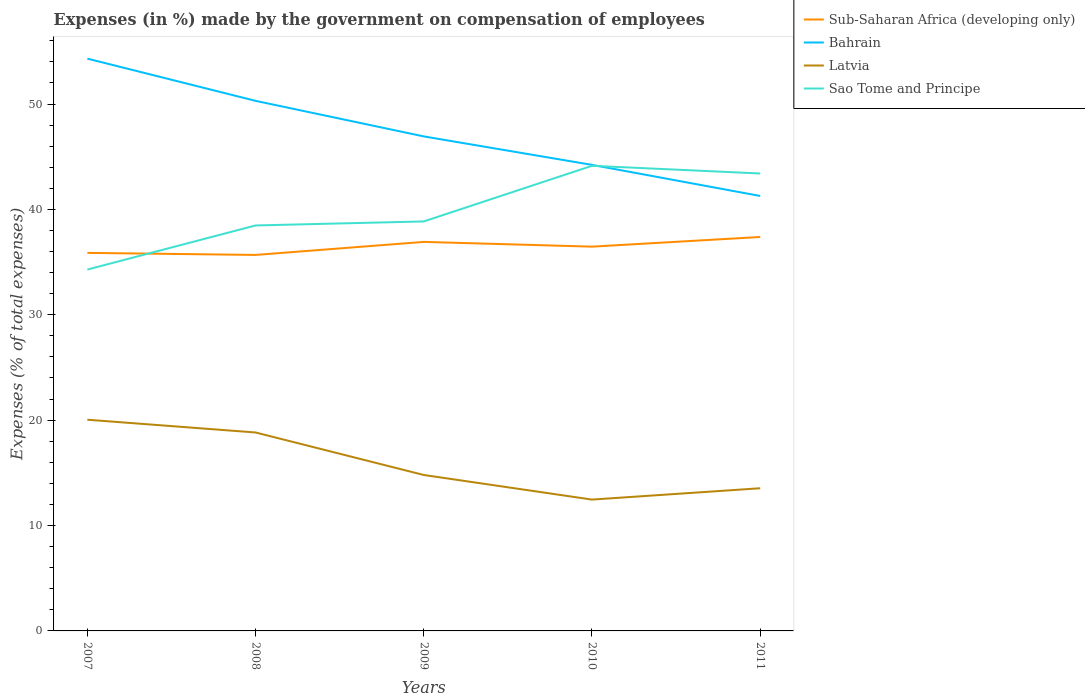How many different coloured lines are there?
Your answer should be very brief. 4. Does the line corresponding to Sub-Saharan Africa (developing only) intersect with the line corresponding to Latvia?
Make the answer very short. No. Across all years, what is the maximum percentage of expenses made by the government on compensation of employees in Sao Tome and Principe?
Your answer should be compact. 34.29. What is the total percentage of expenses made by the government on compensation of employees in Latvia in the graph?
Your answer should be compact. 2.33. What is the difference between the highest and the second highest percentage of expenses made by the government on compensation of employees in Sub-Saharan Africa (developing only)?
Your answer should be compact. 1.7. Is the percentage of expenses made by the government on compensation of employees in Sao Tome and Principe strictly greater than the percentage of expenses made by the government on compensation of employees in Latvia over the years?
Provide a succinct answer. No. Where does the legend appear in the graph?
Give a very brief answer. Top right. How many legend labels are there?
Your answer should be very brief. 4. How are the legend labels stacked?
Provide a short and direct response. Vertical. What is the title of the graph?
Your answer should be very brief. Expenses (in %) made by the government on compensation of employees. What is the label or title of the X-axis?
Provide a succinct answer. Years. What is the label or title of the Y-axis?
Make the answer very short. Expenses (% of total expenses). What is the Expenses (% of total expenses) in Sub-Saharan Africa (developing only) in 2007?
Provide a short and direct response. 35.87. What is the Expenses (% of total expenses) in Bahrain in 2007?
Give a very brief answer. 54.31. What is the Expenses (% of total expenses) in Latvia in 2007?
Offer a terse response. 20.04. What is the Expenses (% of total expenses) in Sao Tome and Principe in 2007?
Your answer should be very brief. 34.29. What is the Expenses (% of total expenses) of Sub-Saharan Africa (developing only) in 2008?
Offer a very short reply. 35.68. What is the Expenses (% of total expenses) in Bahrain in 2008?
Ensure brevity in your answer.  50.3. What is the Expenses (% of total expenses) of Latvia in 2008?
Keep it short and to the point. 18.83. What is the Expenses (% of total expenses) of Sao Tome and Principe in 2008?
Your answer should be compact. 38.48. What is the Expenses (% of total expenses) of Sub-Saharan Africa (developing only) in 2009?
Offer a very short reply. 36.91. What is the Expenses (% of total expenses) of Bahrain in 2009?
Offer a very short reply. 46.93. What is the Expenses (% of total expenses) of Latvia in 2009?
Provide a short and direct response. 14.8. What is the Expenses (% of total expenses) of Sao Tome and Principe in 2009?
Ensure brevity in your answer.  38.86. What is the Expenses (% of total expenses) of Sub-Saharan Africa (developing only) in 2010?
Provide a short and direct response. 36.46. What is the Expenses (% of total expenses) of Bahrain in 2010?
Keep it short and to the point. 44.22. What is the Expenses (% of total expenses) of Latvia in 2010?
Your answer should be very brief. 12.46. What is the Expenses (% of total expenses) of Sao Tome and Principe in 2010?
Your answer should be compact. 44.14. What is the Expenses (% of total expenses) in Sub-Saharan Africa (developing only) in 2011?
Keep it short and to the point. 37.38. What is the Expenses (% of total expenses) of Bahrain in 2011?
Your response must be concise. 41.27. What is the Expenses (% of total expenses) in Latvia in 2011?
Keep it short and to the point. 13.54. What is the Expenses (% of total expenses) in Sao Tome and Principe in 2011?
Offer a very short reply. 43.41. Across all years, what is the maximum Expenses (% of total expenses) of Sub-Saharan Africa (developing only)?
Offer a very short reply. 37.38. Across all years, what is the maximum Expenses (% of total expenses) of Bahrain?
Ensure brevity in your answer.  54.31. Across all years, what is the maximum Expenses (% of total expenses) of Latvia?
Offer a very short reply. 20.04. Across all years, what is the maximum Expenses (% of total expenses) in Sao Tome and Principe?
Your response must be concise. 44.14. Across all years, what is the minimum Expenses (% of total expenses) in Sub-Saharan Africa (developing only)?
Provide a short and direct response. 35.68. Across all years, what is the minimum Expenses (% of total expenses) in Bahrain?
Make the answer very short. 41.27. Across all years, what is the minimum Expenses (% of total expenses) of Latvia?
Provide a short and direct response. 12.46. Across all years, what is the minimum Expenses (% of total expenses) of Sao Tome and Principe?
Keep it short and to the point. 34.29. What is the total Expenses (% of total expenses) in Sub-Saharan Africa (developing only) in the graph?
Your answer should be compact. 182.31. What is the total Expenses (% of total expenses) of Bahrain in the graph?
Make the answer very short. 237.03. What is the total Expenses (% of total expenses) of Latvia in the graph?
Provide a short and direct response. 79.67. What is the total Expenses (% of total expenses) in Sao Tome and Principe in the graph?
Offer a very short reply. 199.16. What is the difference between the Expenses (% of total expenses) in Sub-Saharan Africa (developing only) in 2007 and that in 2008?
Provide a short and direct response. 0.2. What is the difference between the Expenses (% of total expenses) of Bahrain in 2007 and that in 2008?
Provide a succinct answer. 4.01. What is the difference between the Expenses (% of total expenses) in Latvia in 2007 and that in 2008?
Ensure brevity in your answer.  1.21. What is the difference between the Expenses (% of total expenses) of Sao Tome and Principe in 2007 and that in 2008?
Your answer should be compact. -4.19. What is the difference between the Expenses (% of total expenses) of Sub-Saharan Africa (developing only) in 2007 and that in 2009?
Your answer should be compact. -1.04. What is the difference between the Expenses (% of total expenses) of Bahrain in 2007 and that in 2009?
Your answer should be compact. 7.38. What is the difference between the Expenses (% of total expenses) in Latvia in 2007 and that in 2009?
Keep it short and to the point. 5.24. What is the difference between the Expenses (% of total expenses) of Sao Tome and Principe in 2007 and that in 2009?
Ensure brevity in your answer.  -4.57. What is the difference between the Expenses (% of total expenses) in Sub-Saharan Africa (developing only) in 2007 and that in 2010?
Offer a very short reply. -0.59. What is the difference between the Expenses (% of total expenses) in Bahrain in 2007 and that in 2010?
Make the answer very short. 10.08. What is the difference between the Expenses (% of total expenses) of Latvia in 2007 and that in 2010?
Give a very brief answer. 7.58. What is the difference between the Expenses (% of total expenses) in Sao Tome and Principe in 2007 and that in 2010?
Make the answer very short. -9.85. What is the difference between the Expenses (% of total expenses) of Sub-Saharan Africa (developing only) in 2007 and that in 2011?
Provide a succinct answer. -1.51. What is the difference between the Expenses (% of total expenses) of Bahrain in 2007 and that in 2011?
Provide a succinct answer. 13.03. What is the difference between the Expenses (% of total expenses) in Latvia in 2007 and that in 2011?
Offer a very short reply. 6.5. What is the difference between the Expenses (% of total expenses) in Sao Tome and Principe in 2007 and that in 2011?
Make the answer very short. -9.12. What is the difference between the Expenses (% of total expenses) in Sub-Saharan Africa (developing only) in 2008 and that in 2009?
Keep it short and to the point. -1.24. What is the difference between the Expenses (% of total expenses) in Bahrain in 2008 and that in 2009?
Give a very brief answer. 3.37. What is the difference between the Expenses (% of total expenses) of Latvia in 2008 and that in 2009?
Your response must be concise. 4.03. What is the difference between the Expenses (% of total expenses) in Sao Tome and Principe in 2008 and that in 2009?
Ensure brevity in your answer.  -0.38. What is the difference between the Expenses (% of total expenses) of Sub-Saharan Africa (developing only) in 2008 and that in 2010?
Your answer should be compact. -0.79. What is the difference between the Expenses (% of total expenses) of Bahrain in 2008 and that in 2010?
Your response must be concise. 6.08. What is the difference between the Expenses (% of total expenses) of Latvia in 2008 and that in 2010?
Provide a succinct answer. 6.37. What is the difference between the Expenses (% of total expenses) in Sao Tome and Principe in 2008 and that in 2010?
Your response must be concise. -5.66. What is the difference between the Expenses (% of total expenses) of Sub-Saharan Africa (developing only) in 2008 and that in 2011?
Make the answer very short. -1.7. What is the difference between the Expenses (% of total expenses) of Bahrain in 2008 and that in 2011?
Ensure brevity in your answer.  9.03. What is the difference between the Expenses (% of total expenses) of Latvia in 2008 and that in 2011?
Keep it short and to the point. 5.29. What is the difference between the Expenses (% of total expenses) in Sao Tome and Principe in 2008 and that in 2011?
Ensure brevity in your answer.  -4.93. What is the difference between the Expenses (% of total expenses) of Sub-Saharan Africa (developing only) in 2009 and that in 2010?
Your answer should be compact. 0.45. What is the difference between the Expenses (% of total expenses) of Bahrain in 2009 and that in 2010?
Your answer should be compact. 2.7. What is the difference between the Expenses (% of total expenses) of Latvia in 2009 and that in 2010?
Keep it short and to the point. 2.33. What is the difference between the Expenses (% of total expenses) of Sao Tome and Principe in 2009 and that in 2010?
Your answer should be compact. -5.28. What is the difference between the Expenses (% of total expenses) in Sub-Saharan Africa (developing only) in 2009 and that in 2011?
Keep it short and to the point. -0.47. What is the difference between the Expenses (% of total expenses) in Bahrain in 2009 and that in 2011?
Your answer should be compact. 5.65. What is the difference between the Expenses (% of total expenses) in Latvia in 2009 and that in 2011?
Give a very brief answer. 1.26. What is the difference between the Expenses (% of total expenses) in Sao Tome and Principe in 2009 and that in 2011?
Keep it short and to the point. -4.55. What is the difference between the Expenses (% of total expenses) of Sub-Saharan Africa (developing only) in 2010 and that in 2011?
Give a very brief answer. -0.92. What is the difference between the Expenses (% of total expenses) in Bahrain in 2010 and that in 2011?
Your response must be concise. 2.95. What is the difference between the Expenses (% of total expenses) in Latvia in 2010 and that in 2011?
Your answer should be compact. -1.07. What is the difference between the Expenses (% of total expenses) in Sao Tome and Principe in 2010 and that in 2011?
Your answer should be compact. 0.73. What is the difference between the Expenses (% of total expenses) in Sub-Saharan Africa (developing only) in 2007 and the Expenses (% of total expenses) in Bahrain in 2008?
Your response must be concise. -14.43. What is the difference between the Expenses (% of total expenses) of Sub-Saharan Africa (developing only) in 2007 and the Expenses (% of total expenses) of Latvia in 2008?
Offer a terse response. 17.04. What is the difference between the Expenses (% of total expenses) of Sub-Saharan Africa (developing only) in 2007 and the Expenses (% of total expenses) of Sao Tome and Principe in 2008?
Offer a terse response. -2.6. What is the difference between the Expenses (% of total expenses) in Bahrain in 2007 and the Expenses (% of total expenses) in Latvia in 2008?
Your response must be concise. 35.48. What is the difference between the Expenses (% of total expenses) in Bahrain in 2007 and the Expenses (% of total expenses) in Sao Tome and Principe in 2008?
Offer a terse response. 15.83. What is the difference between the Expenses (% of total expenses) of Latvia in 2007 and the Expenses (% of total expenses) of Sao Tome and Principe in 2008?
Provide a short and direct response. -18.43. What is the difference between the Expenses (% of total expenses) in Sub-Saharan Africa (developing only) in 2007 and the Expenses (% of total expenses) in Bahrain in 2009?
Make the answer very short. -11.05. What is the difference between the Expenses (% of total expenses) of Sub-Saharan Africa (developing only) in 2007 and the Expenses (% of total expenses) of Latvia in 2009?
Your answer should be very brief. 21.08. What is the difference between the Expenses (% of total expenses) of Sub-Saharan Africa (developing only) in 2007 and the Expenses (% of total expenses) of Sao Tome and Principe in 2009?
Ensure brevity in your answer.  -2.98. What is the difference between the Expenses (% of total expenses) of Bahrain in 2007 and the Expenses (% of total expenses) of Latvia in 2009?
Make the answer very short. 39.51. What is the difference between the Expenses (% of total expenses) of Bahrain in 2007 and the Expenses (% of total expenses) of Sao Tome and Principe in 2009?
Offer a very short reply. 15.45. What is the difference between the Expenses (% of total expenses) of Latvia in 2007 and the Expenses (% of total expenses) of Sao Tome and Principe in 2009?
Offer a very short reply. -18.81. What is the difference between the Expenses (% of total expenses) of Sub-Saharan Africa (developing only) in 2007 and the Expenses (% of total expenses) of Bahrain in 2010?
Offer a very short reply. -8.35. What is the difference between the Expenses (% of total expenses) in Sub-Saharan Africa (developing only) in 2007 and the Expenses (% of total expenses) in Latvia in 2010?
Provide a short and direct response. 23.41. What is the difference between the Expenses (% of total expenses) of Sub-Saharan Africa (developing only) in 2007 and the Expenses (% of total expenses) of Sao Tome and Principe in 2010?
Your answer should be very brief. -8.26. What is the difference between the Expenses (% of total expenses) in Bahrain in 2007 and the Expenses (% of total expenses) in Latvia in 2010?
Your answer should be very brief. 41.84. What is the difference between the Expenses (% of total expenses) of Bahrain in 2007 and the Expenses (% of total expenses) of Sao Tome and Principe in 2010?
Your answer should be compact. 10.17. What is the difference between the Expenses (% of total expenses) in Latvia in 2007 and the Expenses (% of total expenses) in Sao Tome and Principe in 2010?
Offer a very short reply. -24.09. What is the difference between the Expenses (% of total expenses) in Sub-Saharan Africa (developing only) in 2007 and the Expenses (% of total expenses) in Bahrain in 2011?
Your response must be concise. -5.4. What is the difference between the Expenses (% of total expenses) of Sub-Saharan Africa (developing only) in 2007 and the Expenses (% of total expenses) of Latvia in 2011?
Your answer should be very brief. 22.34. What is the difference between the Expenses (% of total expenses) of Sub-Saharan Africa (developing only) in 2007 and the Expenses (% of total expenses) of Sao Tome and Principe in 2011?
Offer a terse response. -7.53. What is the difference between the Expenses (% of total expenses) in Bahrain in 2007 and the Expenses (% of total expenses) in Latvia in 2011?
Give a very brief answer. 40.77. What is the difference between the Expenses (% of total expenses) of Bahrain in 2007 and the Expenses (% of total expenses) of Sao Tome and Principe in 2011?
Provide a short and direct response. 10.9. What is the difference between the Expenses (% of total expenses) in Latvia in 2007 and the Expenses (% of total expenses) in Sao Tome and Principe in 2011?
Make the answer very short. -23.36. What is the difference between the Expenses (% of total expenses) in Sub-Saharan Africa (developing only) in 2008 and the Expenses (% of total expenses) in Bahrain in 2009?
Offer a terse response. -11.25. What is the difference between the Expenses (% of total expenses) in Sub-Saharan Africa (developing only) in 2008 and the Expenses (% of total expenses) in Latvia in 2009?
Ensure brevity in your answer.  20.88. What is the difference between the Expenses (% of total expenses) of Sub-Saharan Africa (developing only) in 2008 and the Expenses (% of total expenses) of Sao Tome and Principe in 2009?
Keep it short and to the point. -3.18. What is the difference between the Expenses (% of total expenses) in Bahrain in 2008 and the Expenses (% of total expenses) in Latvia in 2009?
Give a very brief answer. 35.5. What is the difference between the Expenses (% of total expenses) in Bahrain in 2008 and the Expenses (% of total expenses) in Sao Tome and Principe in 2009?
Make the answer very short. 11.44. What is the difference between the Expenses (% of total expenses) in Latvia in 2008 and the Expenses (% of total expenses) in Sao Tome and Principe in 2009?
Your answer should be very brief. -20.03. What is the difference between the Expenses (% of total expenses) of Sub-Saharan Africa (developing only) in 2008 and the Expenses (% of total expenses) of Bahrain in 2010?
Offer a terse response. -8.55. What is the difference between the Expenses (% of total expenses) in Sub-Saharan Africa (developing only) in 2008 and the Expenses (% of total expenses) in Latvia in 2010?
Ensure brevity in your answer.  23.22. What is the difference between the Expenses (% of total expenses) in Sub-Saharan Africa (developing only) in 2008 and the Expenses (% of total expenses) in Sao Tome and Principe in 2010?
Your answer should be very brief. -8.46. What is the difference between the Expenses (% of total expenses) in Bahrain in 2008 and the Expenses (% of total expenses) in Latvia in 2010?
Offer a very short reply. 37.84. What is the difference between the Expenses (% of total expenses) of Bahrain in 2008 and the Expenses (% of total expenses) of Sao Tome and Principe in 2010?
Ensure brevity in your answer.  6.16. What is the difference between the Expenses (% of total expenses) in Latvia in 2008 and the Expenses (% of total expenses) in Sao Tome and Principe in 2010?
Provide a short and direct response. -25.31. What is the difference between the Expenses (% of total expenses) in Sub-Saharan Africa (developing only) in 2008 and the Expenses (% of total expenses) in Bahrain in 2011?
Provide a short and direct response. -5.59. What is the difference between the Expenses (% of total expenses) of Sub-Saharan Africa (developing only) in 2008 and the Expenses (% of total expenses) of Latvia in 2011?
Ensure brevity in your answer.  22.14. What is the difference between the Expenses (% of total expenses) in Sub-Saharan Africa (developing only) in 2008 and the Expenses (% of total expenses) in Sao Tome and Principe in 2011?
Provide a short and direct response. -7.73. What is the difference between the Expenses (% of total expenses) in Bahrain in 2008 and the Expenses (% of total expenses) in Latvia in 2011?
Your answer should be compact. 36.76. What is the difference between the Expenses (% of total expenses) in Bahrain in 2008 and the Expenses (% of total expenses) in Sao Tome and Principe in 2011?
Make the answer very short. 6.89. What is the difference between the Expenses (% of total expenses) in Latvia in 2008 and the Expenses (% of total expenses) in Sao Tome and Principe in 2011?
Your response must be concise. -24.58. What is the difference between the Expenses (% of total expenses) in Sub-Saharan Africa (developing only) in 2009 and the Expenses (% of total expenses) in Bahrain in 2010?
Offer a very short reply. -7.31. What is the difference between the Expenses (% of total expenses) of Sub-Saharan Africa (developing only) in 2009 and the Expenses (% of total expenses) of Latvia in 2010?
Provide a short and direct response. 24.45. What is the difference between the Expenses (% of total expenses) in Sub-Saharan Africa (developing only) in 2009 and the Expenses (% of total expenses) in Sao Tome and Principe in 2010?
Offer a very short reply. -7.22. What is the difference between the Expenses (% of total expenses) of Bahrain in 2009 and the Expenses (% of total expenses) of Latvia in 2010?
Keep it short and to the point. 34.46. What is the difference between the Expenses (% of total expenses) in Bahrain in 2009 and the Expenses (% of total expenses) in Sao Tome and Principe in 2010?
Offer a terse response. 2.79. What is the difference between the Expenses (% of total expenses) in Latvia in 2009 and the Expenses (% of total expenses) in Sao Tome and Principe in 2010?
Provide a short and direct response. -29.34. What is the difference between the Expenses (% of total expenses) in Sub-Saharan Africa (developing only) in 2009 and the Expenses (% of total expenses) in Bahrain in 2011?
Your response must be concise. -4.36. What is the difference between the Expenses (% of total expenses) in Sub-Saharan Africa (developing only) in 2009 and the Expenses (% of total expenses) in Latvia in 2011?
Your answer should be very brief. 23.38. What is the difference between the Expenses (% of total expenses) in Sub-Saharan Africa (developing only) in 2009 and the Expenses (% of total expenses) in Sao Tome and Principe in 2011?
Your answer should be very brief. -6.49. What is the difference between the Expenses (% of total expenses) of Bahrain in 2009 and the Expenses (% of total expenses) of Latvia in 2011?
Keep it short and to the point. 33.39. What is the difference between the Expenses (% of total expenses) in Bahrain in 2009 and the Expenses (% of total expenses) in Sao Tome and Principe in 2011?
Your answer should be very brief. 3.52. What is the difference between the Expenses (% of total expenses) of Latvia in 2009 and the Expenses (% of total expenses) of Sao Tome and Principe in 2011?
Ensure brevity in your answer.  -28.61. What is the difference between the Expenses (% of total expenses) of Sub-Saharan Africa (developing only) in 2010 and the Expenses (% of total expenses) of Bahrain in 2011?
Your answer should be very brief. -4.81. What is the difference between the Expenses (% of total expenses) in Sub-Saharan Africa (developing only) in 2010 and the Expenses (% of total expenses) in Latvia in 2011?
Ensure brevity in your answer.  22.93. What is the difference between the Expenses (% of total expenses) in Sub-Saharan Africa (developing only) in 2010 and the Expenses (% of total expenses) in Sao Tome and Principe in 2011?
Your response must be concise. -6.94. What is the difference between the Expenses (% of total expenses) in Bahrain in 2010 and the Expenses (% of total expenses) in Latvia in 2011?
Keep it short and to the point. 30.69. What is the difference between the Expenses (% of total expenses) in Bahrain in 2010 and the Expenses (% of total expenses) in Sao Tome and Principe in 2011?
Give a very brief answer. 0.82. What is the difference between the Expenses (% of total expenses) in Latvia in 2010 and the Expenses (% of total expenses) in Sao Tome and Principe in 2011?
Your answer should be very brief. -30.94. What is the average Expenses (% of total expenses) of Sub-Saharan Africa (developing only) per year?
Your response must be concise. 36.46. What is the average Expenses (% of total expenses) of Bahrain per year?
Offer a very short reply. 47.41. What is the average Expenses (% of total expenses) in Latvia per year?
Make the answer very short. 15.93. What is the average Expenses (% of total expenses) of Sao Tome and Principe per year?
Provide a succinct answer. 39.83. In the year 2007, what is the difference between the Expenses (% of total expenses) of Sub-Saharan Africa (developing only) and Expenses (% of total expenses) of Bahrain?
Make the answer very short. -18.43. In the year 2007, what is the difference between the Expenses (% of total expenses) in Sub-Saharan Africa (developing only) and Expenses (% of total expenses) in Latvia?
Your answer should be very brief. 15.83. In the year 2007, what is the difference between the Expenses (% of total expenses) of Sub-Saharan Africa (developing only) and Expenses (% of total expenses) of Sao Tome and Principe?
Your answer should be compact. 1.58. In the year 2007, what is the difference between the Expenses (% of total expenses) in Bahrain and Expenses (% of total expenses) in Latvia?
Your answer should be very brief. 34.26. In the year 2007, what is the difference between the Expenses (% of total expenses) of Bahrain and Expenses (% of total expenses) of Sao Tome and Principe?
Make the answer very short. 20.02. In the year 2007, what is the difference between the Expenses (% of total expenses) in Latvia and Expenses (% of total expenses) in Sao Tome and Principe?
Offer a very short reply. -14.25. In the year 2008, what is the difference between the Expenses (% of total expenses) in Sub-Saharan Africa (developing only) and Expenses (% of total expenses) in Bahrain?
Make the answer very short. -14.62. In the year 2008, what is the difference between the Expenses (% of total expenses) in Sub-Saharan Africa (developing only) and Expenses (% of total expenses) in Latvia?
Provide a succinct answer. 16.85. In the year 2008, what is the difference between the Expenses (% of total expenses) of Sub-Saharan Africa (developing only) and Expenses (% of total expenses) of Sao Tome and Principe?
Make the answer very short. -2.8. In the year 2008, what is the difference between the Expenses (% of total expenses) of Bahrain and Expenses (% of total expenses) of Latvia?
Keep it short and to the point. 31.47. In the year 2008, what is the difference between the Expenses (% of total expenses) in Bahrain and Expenses (% of total expenses) in Sao Tome and Principe?
Your answer should be compact. 11.82. In the year 2008, what is the difference between the Expenses (% of total expenses) of Latvia and Expenses (% of total expenses) of Sao Tome and Principe?
Provide a short and direct response. -19.65. In the year 2009, what is the difference between the Expenses (% of total expenses) in Sub-Saharan Africa (developing only) and Expenses (% of total expenses) in Bahrain?
Keep it short and to the point. -10.01. In the year 2009, what is the difference between the Expenses (% of total expenses) of Sub-Saharan Africa (developing only) and Expenses (% of total expenses) of Latvia?
Your response must be concise. 22.12. In the year 2009, what is the difference between the Expenses (% of total expenses) in Sub-Saharan Africa (developing only) and Expenses (% of total expenses) in Sao Tome and Principe?
Your answer should be compact. -1.94. In the year 2009, what is the difference between the Expenses (% of total expenses) in Bahrain and Expenses (% of total expenses) in Latvia?
Ensure brevity in your answer.  32.13. In the year 2009, what is the difference between the Expenses (% of total expenses) of Bahrain and Expenses (% of total expenses) of Sao Tome and Principe?
Make the answer very short. 8.07. In the year 2009, what is the difference between the Expenses (% of total expenses) in Latvia and Expenses (% of total expenses) in Sao Tome and Principe?
Provide a succinct answer. -24.06. In the year 2010, what is the difference between the Expenses (% of total expenses) of Sub-Saharan Africa (developing only) and Expenses (% of total expenses) of Bahrain?
Give a very brief answer. -7.76. In the year 2010, what is the difference between the Expenses (% of total expenses) in Sub-Saharan Africa (developing only) and Expenses (% of total expenses) in Latvia?
Your answer should be very brief. 24. In the year 2010, what is the difference between the Expenses (% of total expenses) in Sub-Saharan Africa (developing only) and Expenses (% of total expenses) in Sao Tome and Principe?
Ensure brevity in your answer.  -7.67. In the year 2010, what is the difference between the Expenses (% of total expenses) in Bahrain and Expenses (% of total expenses) in Latvia?
Provide a succinct answer. 31.76. In the year 2010, what is the difference between the Expenses (% of total expenses) in Bahrain and Expenses (% of total expenses) in Sao Tome and Principe?
Offer a very short reply. 0.09. In the year 2010, what is the difference between the Expenses (% of total expenses) of Latvia and Expenses (% of total expenses) of Sao Tome and Principe?
Give a very brief answer. -31.67. In the year 2011, what is the difference between the Expenses (% of total expenses) of Sub-Saharan Africa (developing only) and Expenses (% of total expenses) of Bahrain?
Provide a short and direct response. -3.89. In the year 2011, what is the difference between the Expenses (% of total expenses) in Sub-Saharan Africa (developing only) and Expenses (% of total expenses) in Latvia?
Offer a terse response. 23.84. In the year 2011, what is the difference between the Expenses (% of total expenses) of Sub-Saharan Africa (developing only) and Expenses (% of total expenses) of Sao Tome and Principe?
Make the answer very short. -6.03. In the year 2011, what is the difference between the Expenses (% of total expenses) of Bahrain and Expenses (% of total expenses) of Latvia?
Ensure brevity in your answer.  27.74. In the year 2011, what is the difference between the Expenses (% of total expenses) in Bahrain and Expenses (% of total expenses) in Sao Tome and Principe?
Your response must be concise. -2.13. In the year 2011, what is the difference between the Expenses (% of total expenses) of Latvia and Expenses (% of total expenses) of Sao Tome and Principe?
Keep it short and to the point. -29.87. What is the ratio of the Expenses (% of total expenses) of Sub-Saharan Africa (developing only) in 2007 to that in 2008?
Keep it short and to the point. 1.01. What is the ratio of the Expenses (% of total expenses) in Bahrain in 2007 to that in 2008?
Your answer should be very brief. 1.08. What is the ratio of the Expenses (% of total expenses) of Latvia in 2007 to that in 2008?
Your answer should be compact. 1.06. What is the ratio of the Expenses (% of total expenses) of Sao Tome and Principe in 2007 to that in 2008?
Keep it short and to the point. 0.89. What is the ratio of the Expenses (% of total expenses) in Sub-Saharan Africa (developing only) in 2007 to that in 2009?
Your answer should be very brief. 0.97. What is the ratio of the Expenses (% of total expenses) of Bahrain in 2007 to that in 2009?
Provide a succinct answer. 1.16. What is the ratio of the Expenses (% of total expenses) of Latvia in 2007 to that in 2009?
Your answer should be very brief. 1.35. What is the ratio of the Expenses (% of total expenses) of Sao Tome and Principe in 2007 to that in 2009?
Your answer should be compact. 0.88. What is the ratio of the Expenses (% of total expenses) of Sub-Saharan Africa (developing only) in 2007 to that in 2010?
Your answer should be very brief. 0.98. What is the ratio of the Expenses (% of total expenses) of Bahrain in 2007 to that in 2010?
Provide a succinct answer. 1.23. What is the ratio of the Expenses (% of total expenses) in Latvia in 2007 to that in 2010?
Your response must be concise. 1.61. What is the ratio of the Expenses (% of total expenses) of Sao Tome and Principe in 2007 to that in 2010?
Your response must be concise. 0.78. What is the ratio of the Expenses (% of total expenses) in Sub-Saharan Africa (developing only) in 2007 to that in 2011?
Keep it short and to the point. 0.96. What is the ratio of the Expenses (% of total expenses) of Bahrain in 2007 to that in 2011?
Give a very brief answer. 1.32. What is the ratio of the Expenses (% of total expenses) of Latvia in 2007 to that in 2011?
Your answer should be compact. 1.48. What is the ratio of the Expenses (% of total expenses) of Sao Tome and Principe in 2007 to that in 2011?
Ensure brevity in your answer.  0.79. What is the ratio of the Expenses (% of total expenses) in Sub-Saharan Africa (developing only) in 2008 to that in 2009?
Offer a very short reply. 0.97. What is the ratio of the Expenses (% of total expenses) in Bahrain in 2008 to that in 2009?
Give a very brief answer. 1.07. What is the ratio of the Expenses (% of total expenses) of Latvia in 2008 to that in 2009?
Provide a short and direct response. 1.27. What is the ratio of the Expenses (% of total expenses) in Sao Tome and Principe in 2008 to that in 2009?
Your response must be concise. 0.99. What is the ratio of the Expenses (% of total expenses) of Sub-Saharan Africa (developing only) in 2008 to that in 2010?
Offer a terse response. 0.98. What is the ratio of the Expenses (% of total expenses) in Bahrain in 2008 to that in 2010?
Offer a very short reply. 1.14. What is the ratio of the Expenses (% of total expenses) of Latvia in 2008 to that in 2010?
Keep it short and to the point. 1.51. What is the ratio of the Expenses (% of total expenses) in Sao Tome and Principe in 2008 to that in 2010?
Your answer should be compact. 0.87. What is the ratio of the Expenses (% of total expenses) in Sub-Saharan Africa (developing only) in 2008 to that in 2011?
Offer a terse response. 0.95. What is the ratio of the Expenses (% of total expenses) of Bahrain in 2008 to that in 2011?
Your answer should be very brief. 1.22. What is the ratio of the Expenses (% of total expenses) of Latvia in 2008 to that in 2011?
Your answer should be compact. 1.39. What is the ratio of the Expenses (% of total expenses) in Sao Tome and Principe in 2008 to that in 2011?
Keep it short and to the point. 0.89. What is the ratio of the Expenses (% of total expenses) of Sub-Saharan Africa (developing only) in 2009 to that in 2010?
Make the answer very short. 1.01. What is the ratio of the Expenses (% of total expenses) of Bahrain in 2009 to that in 2010?
Your answer should be very brief. 1.06. What is the ratio of the Expenses (% of total expenses) in Latvia in 2009 to that in 2010?
Your answer should be very brief. 1.19. What is the ratio of the Expenses (% of total expenses) in Sao Tome and Principe in 2009 to that in 2010?
Your response must be concise. 0.88. What is the ratio of the Expenses (% of total expenses) in Sub-Saharan Africa (developing only) in 2009 to that in 2011?
Provide a short and direct response. 0.99. What is the ratio of the Expenses (% of total expenses) of Bahrain in 2009 to that in 2011?
Your answer should be very brief. 1.14. What is the ratio of the Expenses (% of total expenses) of Latvia in 2009 to that in 2011?
Keep it short and to the point. 1.09. What is the ratio of the Expenses (% of total expenses) in Sao Tome and Principe in 2009 to that in 2011?
Keep it short and to the point. 0.9. What is the ratio of the Expenses (% of total expenses) of Sub-Saharan Africa (developing only) in 2010 to that in 2011?
Provide a succinct answer. 0.98. What is the ratio of the Expenses (% of total expenses) of Bahrain in 2010 to that in 2011?
Give a very brief answer. 1.07. What is the ratio of the Expenses (% of total expenses) of Latvia in 2010 to that in 2011?
Your answer should be compact. 0.92. What is the ratio of the Expenses (% of total expenses) of Sao Tome and Principe in 2010 to that in 2011?
Your response must be concise. 1.02. What is the difference between the highest and the second highest Expenses (% of total expenses) of Sub-Saharan Africa (developing only)?
Offer a terse response. 0.47. What is the difference between the highest and the second highest Expenses (% of total expenses) of Bahrain?
Keep it short and to the point. 4.01. What is the difference between the highest and the second highest Expenses (% of total expenses) in Latvia?
Offer a terse response. 1.21. What is the difference between the highest and the second highest Expenses (% of total expenses) in Sao Tome and Principe?
Make the answer very short. 0.73. What is the difference between the highest and the lowest Expenses (% of total expenses) in Sub-Saharan Africa (developing only)?
Provide a short and direct response. 1.7. What is the difference between the highest and the lowest Expenses (% of total expenses) in Bahrain?
Offer a terse response. 13.03. What is the difference between the highest and the lowest Expenses (% of total expenses) in Latvia?
Offer a terse response. 7.58. What is the difference between the highest and the lowest Expenses (% of total expenses) of Sao Tome and Principe?
Your response must be concise. 9.85. 